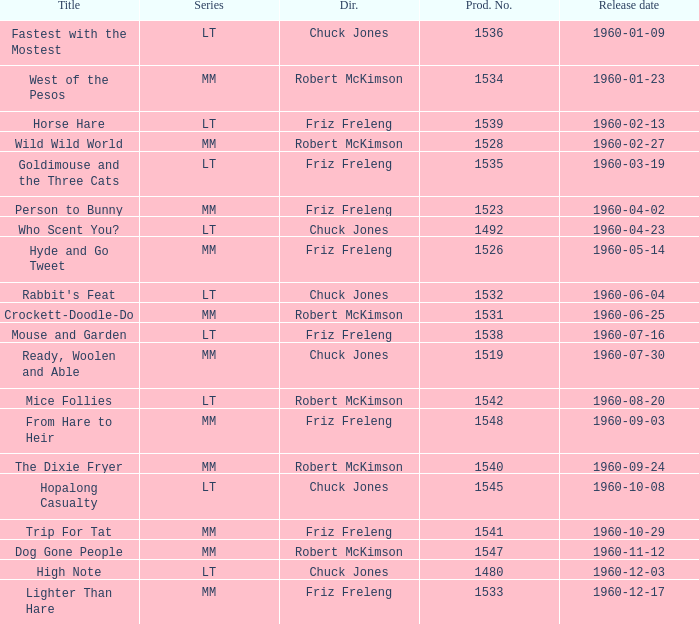What is the production number of From Hare to Heir? 1548.0. 